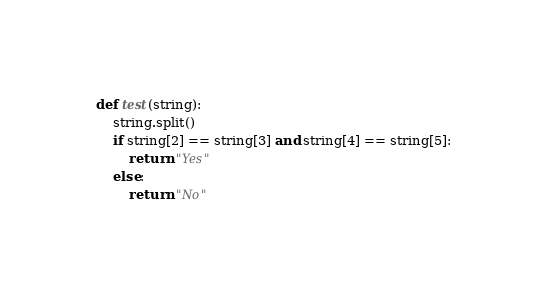<code> <loc_0><loc_0><loc_500><loc_500><_Python_>def test(string):
    string.split()
    if string[2] == string[3] and string[4] == string[5]:
        return "Yes"
    else:
        return "No"</code> 